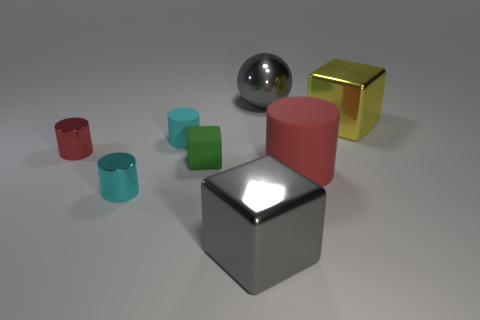Subtract all small cyan metal cylinders. How many cylinders are left? 3 Subtract all green spheres. How many cyan cylinders are left? 2 Add 1 green matte objects. How many objects exist? 9 Subtract all cyan cylinders. How many cylinders are left? 2 Subtract all cubes. How many objects are left? 5 Subtract all gray cubes. Subtract all green spheres. How many cubes are left? 2 Subtract all small green blocks. Subtract all large gray shiny objects. How many objects are left? 5 Add 1 red cylinders. How many red cylinders are left? 3 Add 6 large gray metallic blocks. How many large gray metallic blocks exist? 7 Subtract 0 blue blocks. How many objects are left? 8 